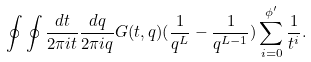Convert formula to latex. <formula><loc_0><loc_0><loc_500><loc_500>\oint \oint \frac { d t } { 2 \pi i t } \frac { d q } { 2 \pi i q } G ( t , q ) ( \frac { 1 } { q ^ { L } } - \frac { 1 } { q ^ { L - 1 } } ) \sum _ { i = 0 } ^ { \phi ^ { \prime } } \frac { 1 } { t ^ { i } } .</formula> 